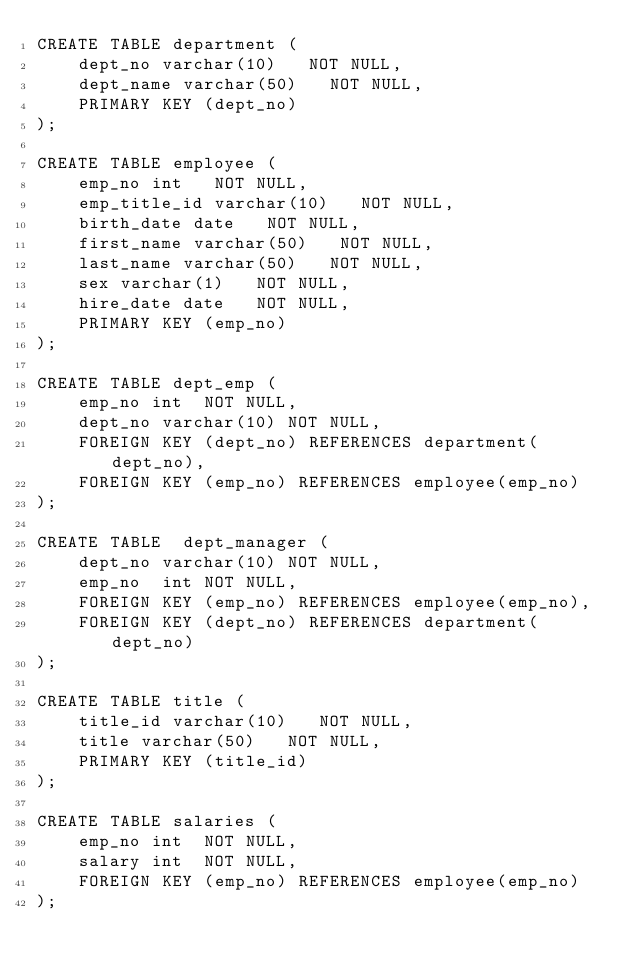Convert code to text. <code><loc_0><loc_0><loc_500><loc_500><_SQL_>CREATE TABLE department (
    dept_no varchar(10)   NOT NULL,
    dept_name varchar(50)   NOT NULL,
    PRIMARY KEY (dept_no)
);

CREATE TABLE employee (
    emp_no int   NOT NULL,
    emp_title_id varchar(10)   NOT NULL,
    birth_date date   NOT NULL,
    first_name varchar(50)   NOT NULL,
    last_name varchar(50)   NOT NULL,
    sex varchar(1)   NOT NULL,
    hire_date date   NOT NULL,
	PRIMARY KEY (emp_no)
);

CREATE TABLE dept_emp (
	emp_no int	NOT NULL,
	dept_no varchar(10)	NOT NULL,
	FOREIGN KEY (dept_no) REFERENCES department(dept_no),
	FOREIGN KEY (emp_no) REFERENCES employee(emp_no)
);

CREATE TABLE  dept_manager (
	dept_no varchar(10)	NOT NULL,
	emp_no	int	NOT NULL,
	FOREIGN KEY (emp_no) REFERENCES employee(emp_no),
	FOREIGN KEY (dept_no) REFERENCES department(dept_no)
);

CREATE TABLE title (
    title_id varchar(10)   NOT NULL,
    title varchar(50)   NOT NULL,
	PRIMARY KEY (title_id)
);

CREATE TABLE salaries (
	emp_no int	NOT NULL,
	salary int	NOT NULL,
	FOREIGN KEY (emp_no) REFERENCES employee(emp_no)
);

</code> 